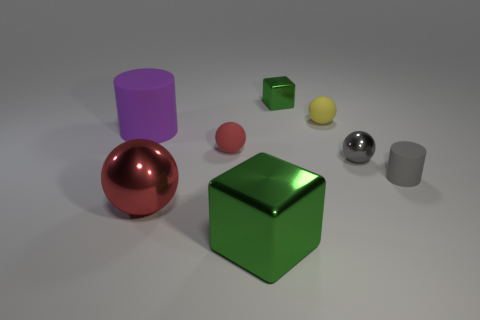Which objects seem to have a reflective surface, and how can you tell? The silver sphere and the big gray block to the right have reflective surfaces, as indicated by the clear reflections and highlights on their exteriors that mirror the environment and lighting. 